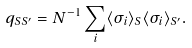<formula> <loc_0><loc_0><loc_500><loc_500>q _ { S S ^ { \prime } } = N ^ { - 1 } \sum _ { i } \langle \sigma _ { i } \rangle _ { S } \langle \sigma _ { i } \rangle _ { S ^ { \prime } } .</formula> 